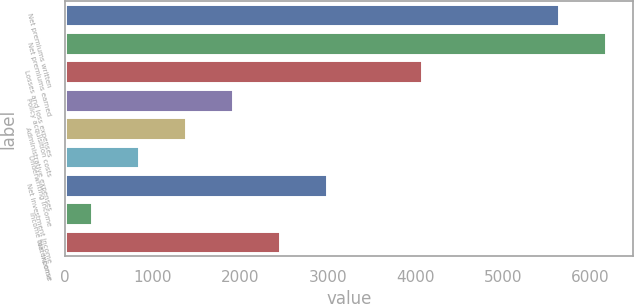Convert chart. <chart><loc_0><loc_0><loc_500><loc_500><bar_chart><fcel>Net premiums written<fcel>Net premiums earned<fcel>Losses and loss expenses<fcel>Policy acquisition costs<fcel>Administrative expenses<fcel>Underwriting income<fcel>Net investment income<fcel>Income tax expense<fcel>Net income<nl><fcel>5636<fcel>6172.4<fcel>4080<fcel>1924.2<fcel>1387.8<fcel>851.4<fcel>2997<fcel>315<fcel>2460.6<nl></chart> 